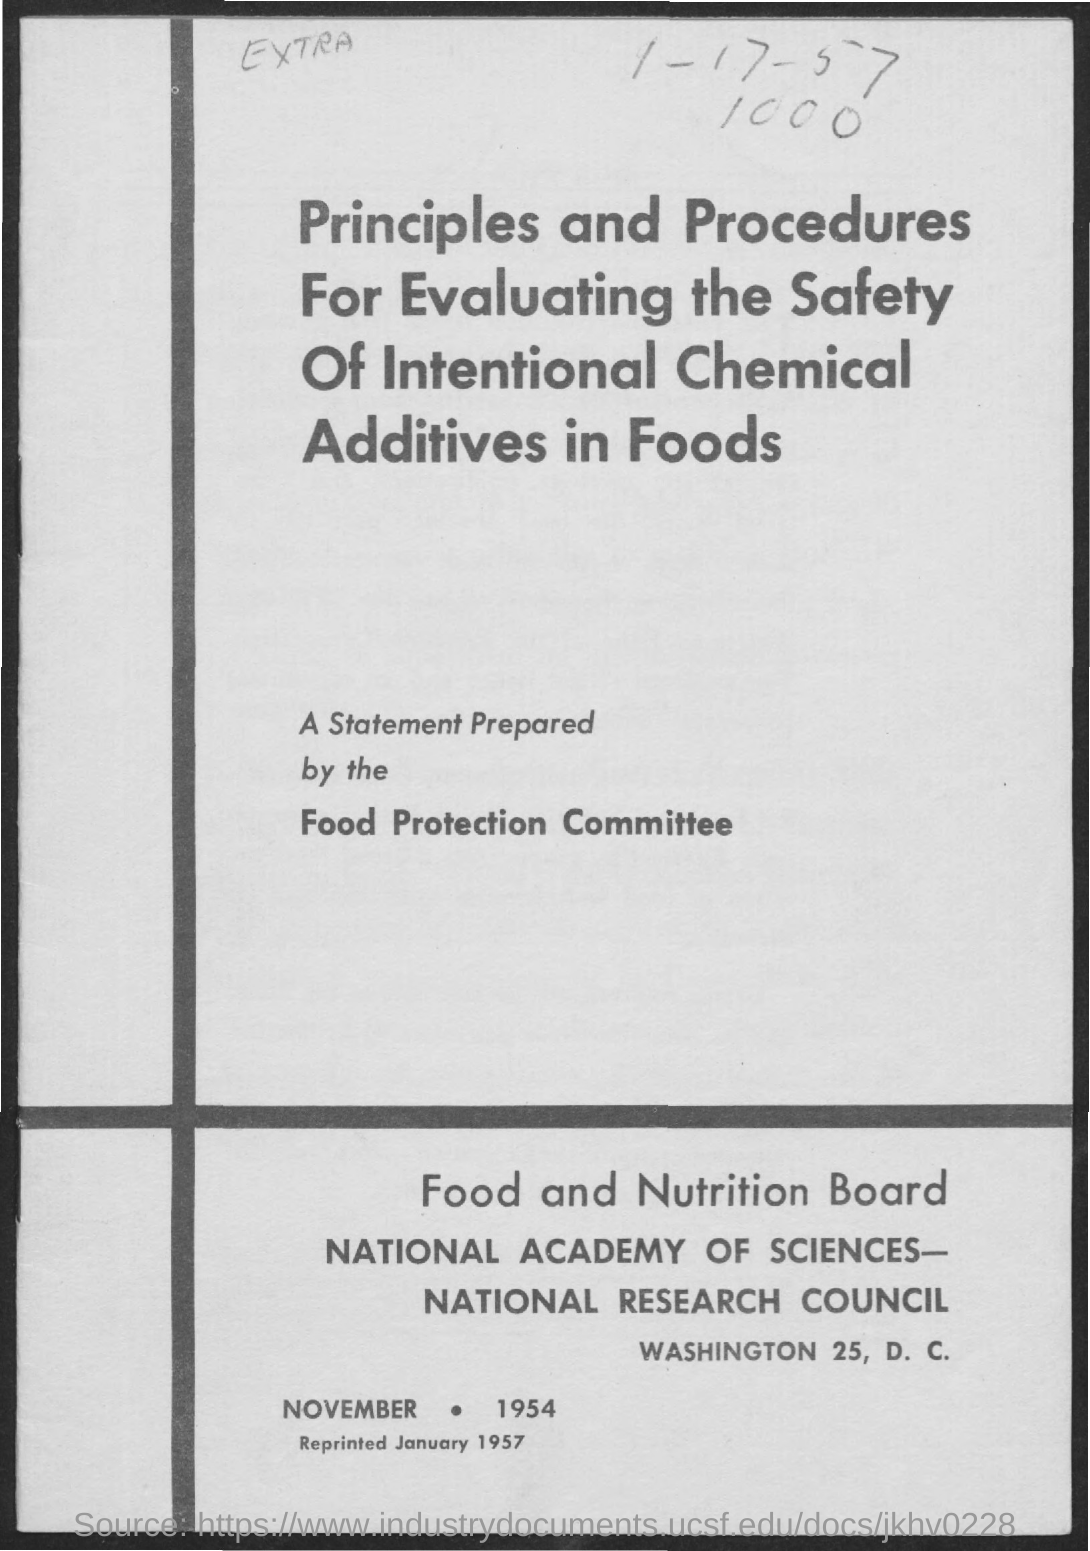Who prepared the statement?
Offer a very short reply. Food Protection Committee. What is the Place?
Give a very brief answer. Washington 25, D. C. 